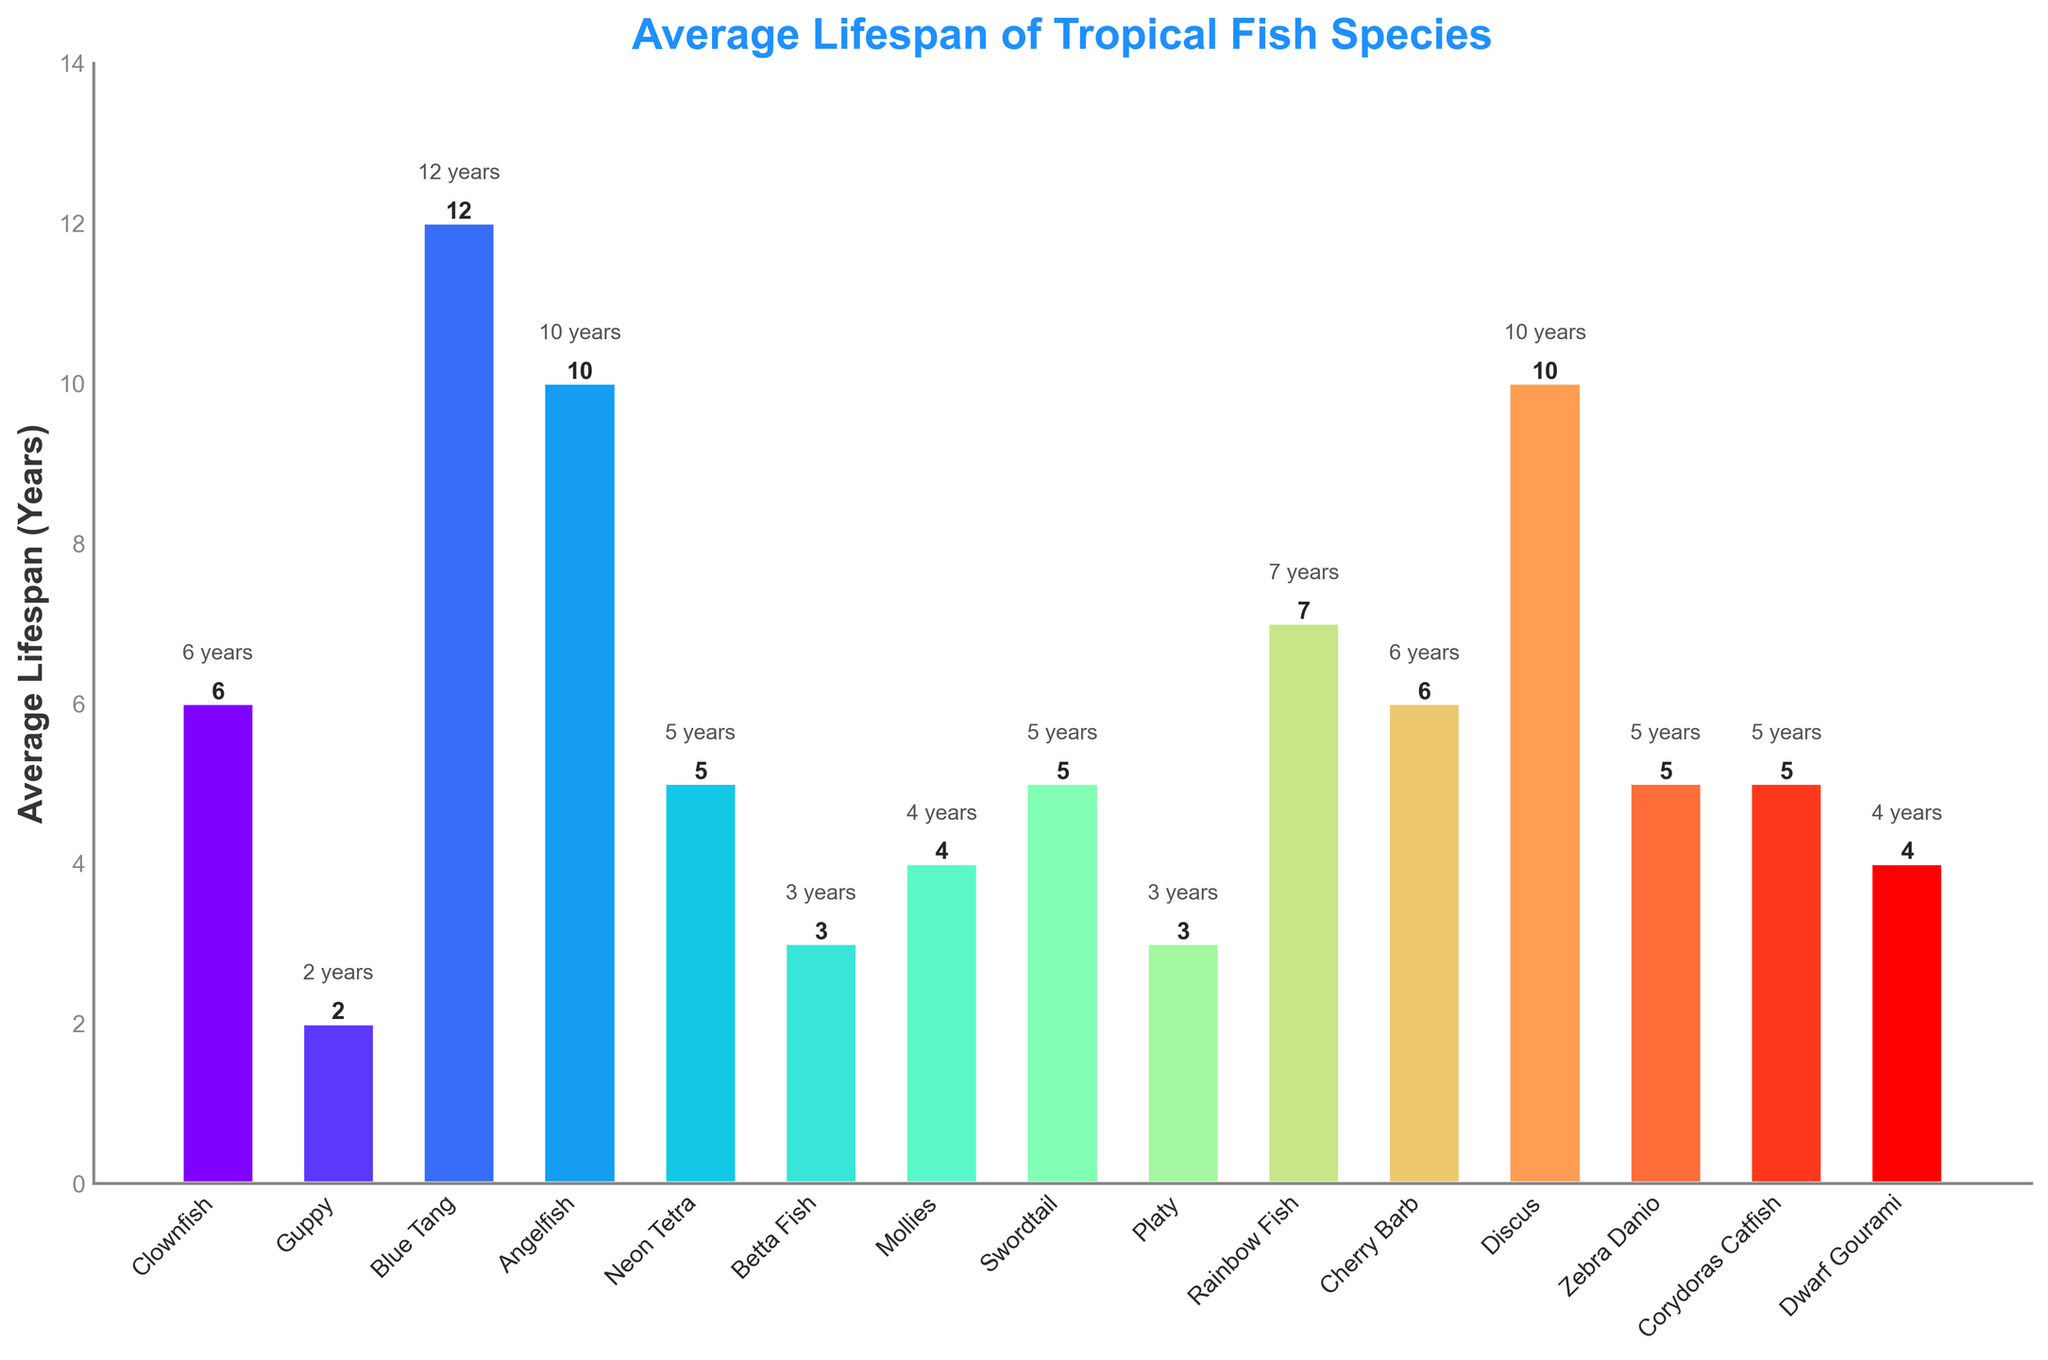Which fish species has the longest average lifespan? The bars in the chart visually represent the average lifespan of different fish species. The tallest bar corresponds to the longest lifespan. The Blue Tang has the highest bar with an average lifespan of 12 years.
Answer: Blue Tang Which fish species has the shortest average lifespan? Observing the shortest bar in the chart, the Guppy has the shortest average lifespan of 2 years.
Answer: Guppy What is the lifespan difference between Clownfish and Betta Fish? The Clownfish has an average lifespan of 6 years, and the Betta Fish has an average lifespan of 3 years. The difference is calculated as 6 - 3.
Answer: 3 years How many fish species have an average lifespan of 5 years? By checking the labels and corresponding bars in the chart, we can see that the Neon Tetra, Swordtail, Zebra Danio, and Corydoras Catfish have lifespans of 5 years.
Answer: 4 species What is the total average lifespan of Guppy, Mollies, and Dwarf Gourami combined? The lifespans of the Guppy, Mollies, and Dwarf Gourami are 2, 4, and 4 years respectively. Adding them, 2 + 4 + 4 equals 10 years.
Answer: 10 years Which fish species has more years in average lifespan: Cherry Barb or Rainbow Fish? The Cherry Barb has an average lifespan of 6 years, while the Rainbow Fish has an average lifespan of 7 years. Comparing these, Rainbow Fish's lifespan is greater.
Answer: Rainbow Fish Compare the average lifespan of Clownfish and Cherry Barb. Is there any difference? Both the Clownfish and Cherry Barb have bars reaching the 6-year mark, implying they have equal average lifespans.
Answer: No difference How much longer on average does an Angelfish live compared to a Betta Fish? The Angelfish has an average lifespan of 10 years, and the Betta Fish has 3 years. The difference is 10 - 3.
Answer: 7 years What is the average lifespan of the fish species that live for 10 years? From the chart, Angelfish and Discus have an average lifespan of 10 years. Their combined average lifespan is calculated as (10 + 10) / 2 = 10 years.
Answer: 10 years 